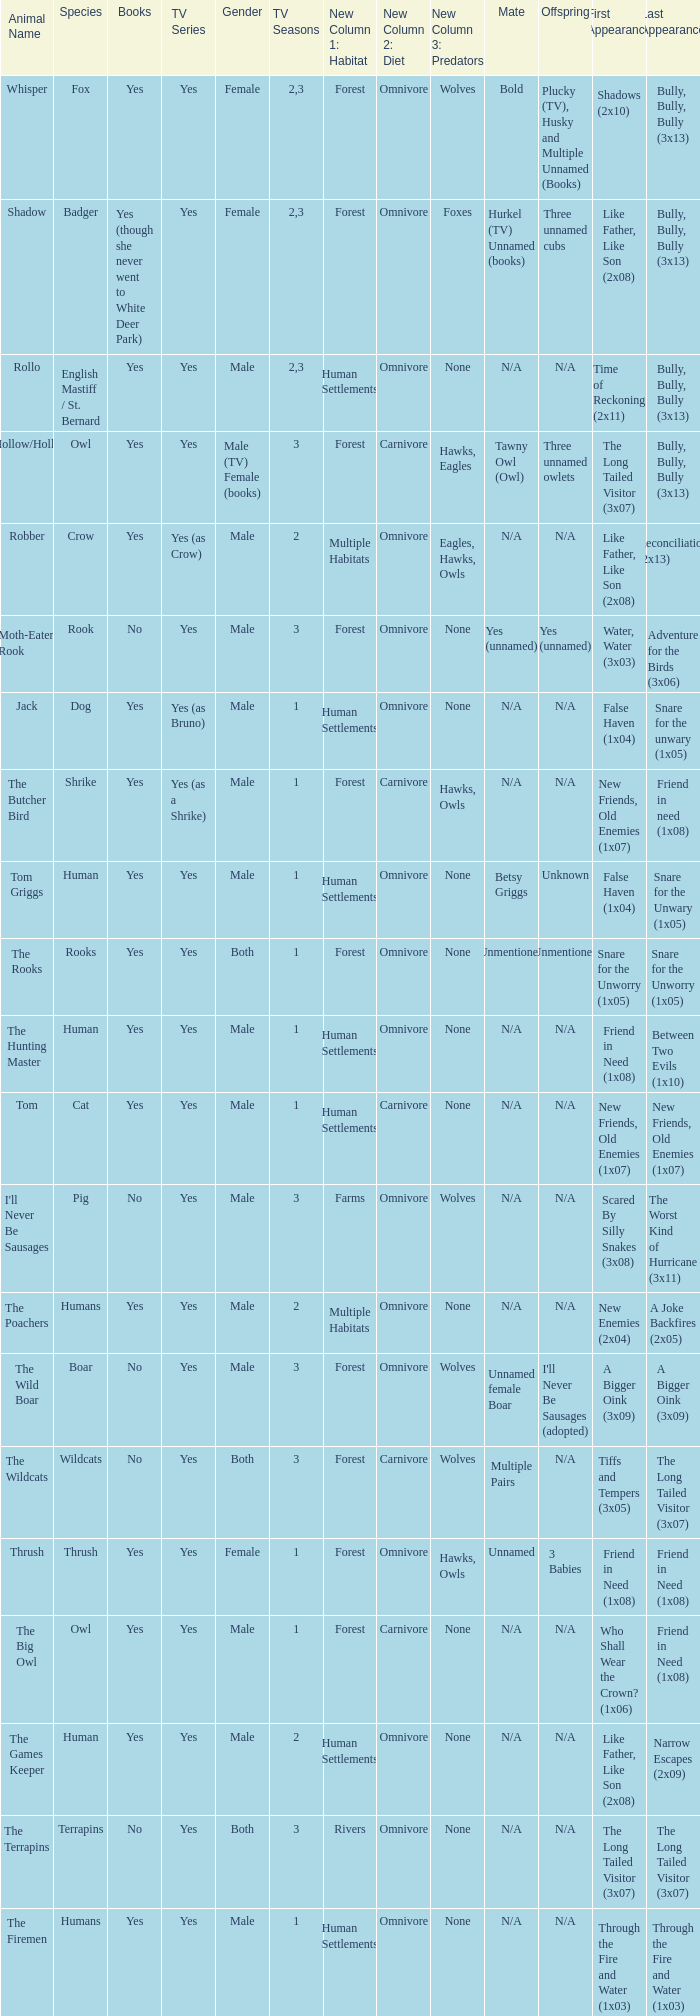What is the smallest season for a tv series with a yes and human was the species? 1.0. 